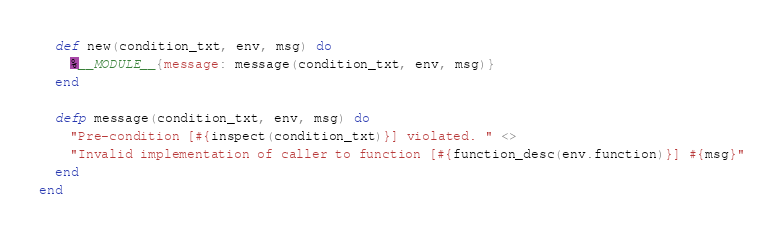<code> <loc_0><loc_0><loc_500><loc_500><_Elixir_>  def new(condition_txt, env, msg) do
    %__MODULE__{message: message(condition_txt, env, msg)}
  end

  defp message(condition_txt, env, msg) do
    "Pre-condition [#{inspect(condition_txt)}] violated. " <>
    "Invalid implementation of caller to function [#{function_desc(env.function)}] #{msg}"
  end
end
</code> 